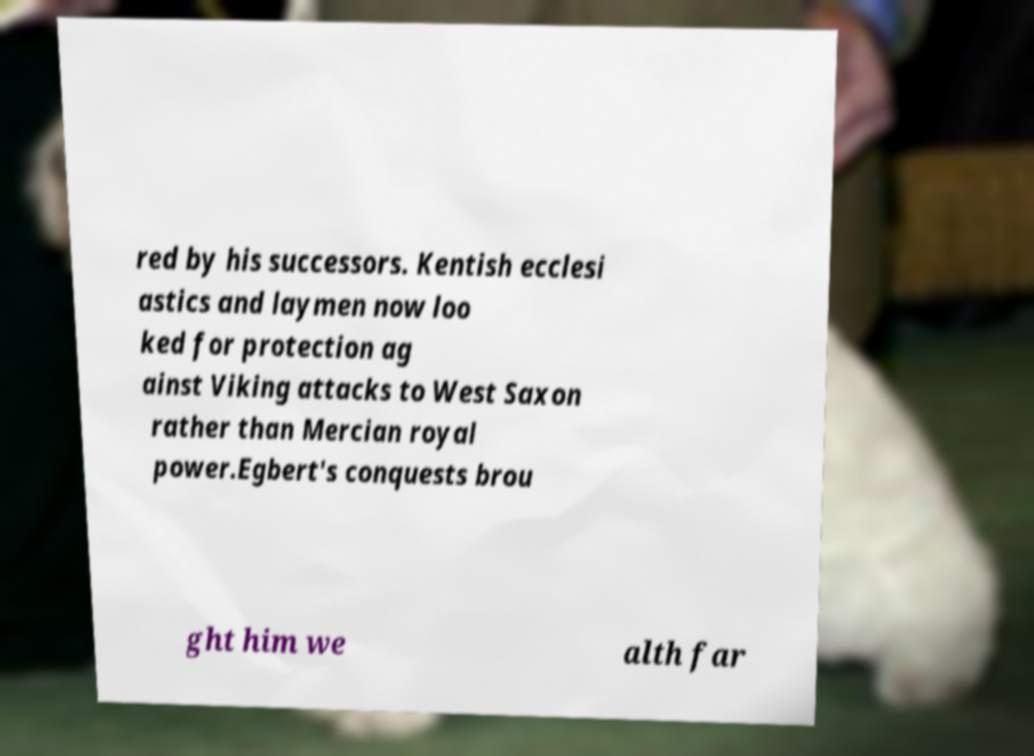Please read and relay the text visible in this image. What does it say? red by his successors. Kentish ecclesi astics and laymen now loo ked for protection ag ainst Viking attacks to West Saxon rather than Mercian royal power.Egbert's conquests brou ght him we alth far 